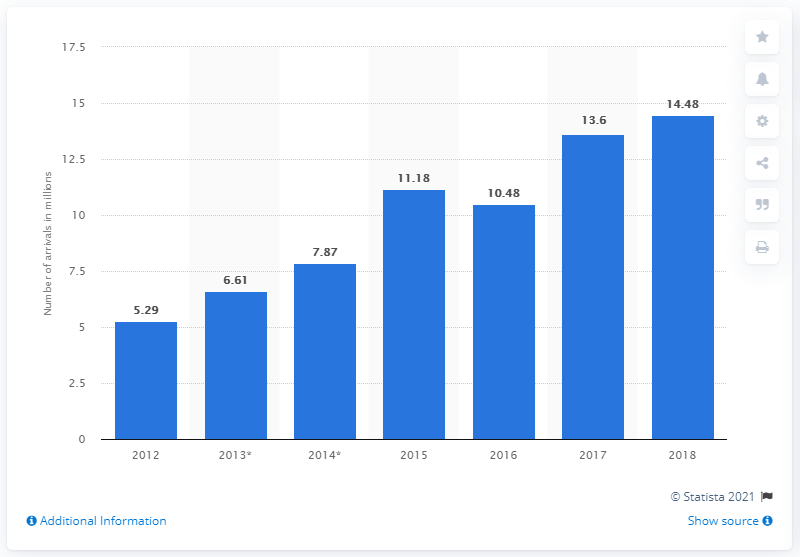Identify some key points in this picture. In 2018, a total of 14,480 tourist arrivals from China and Hong Kong stayed in accommodation establishments within the European Union. 